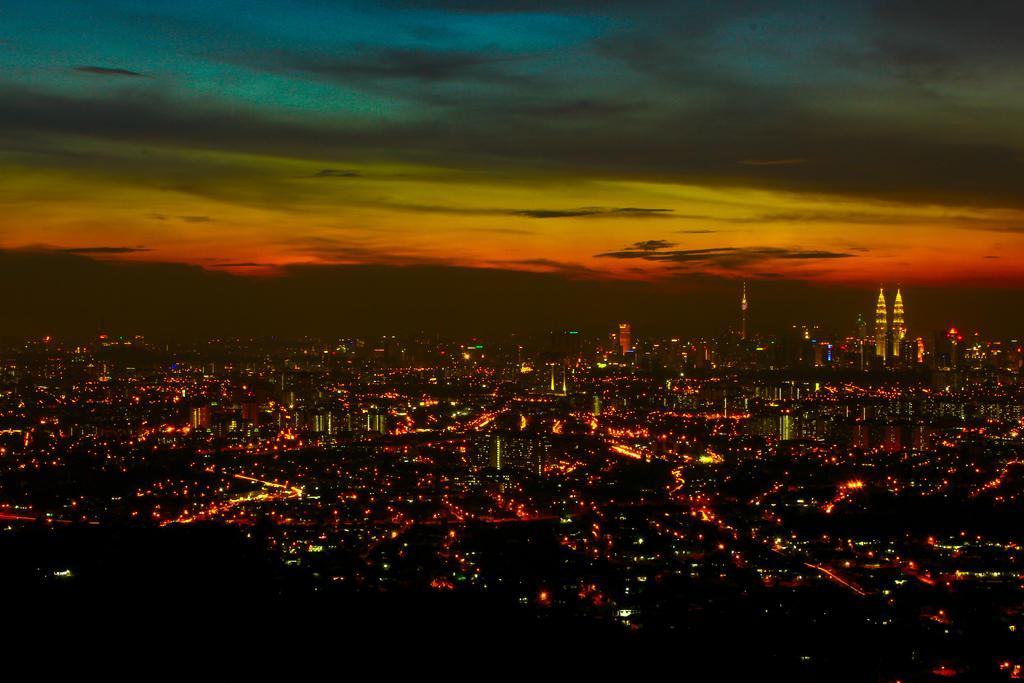Describe this image in one or two sentences. In this picture we can see many buildings and colorful lights from left to right. Sky is cloudy. 